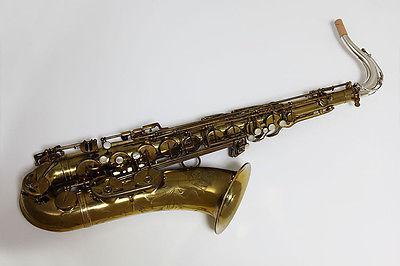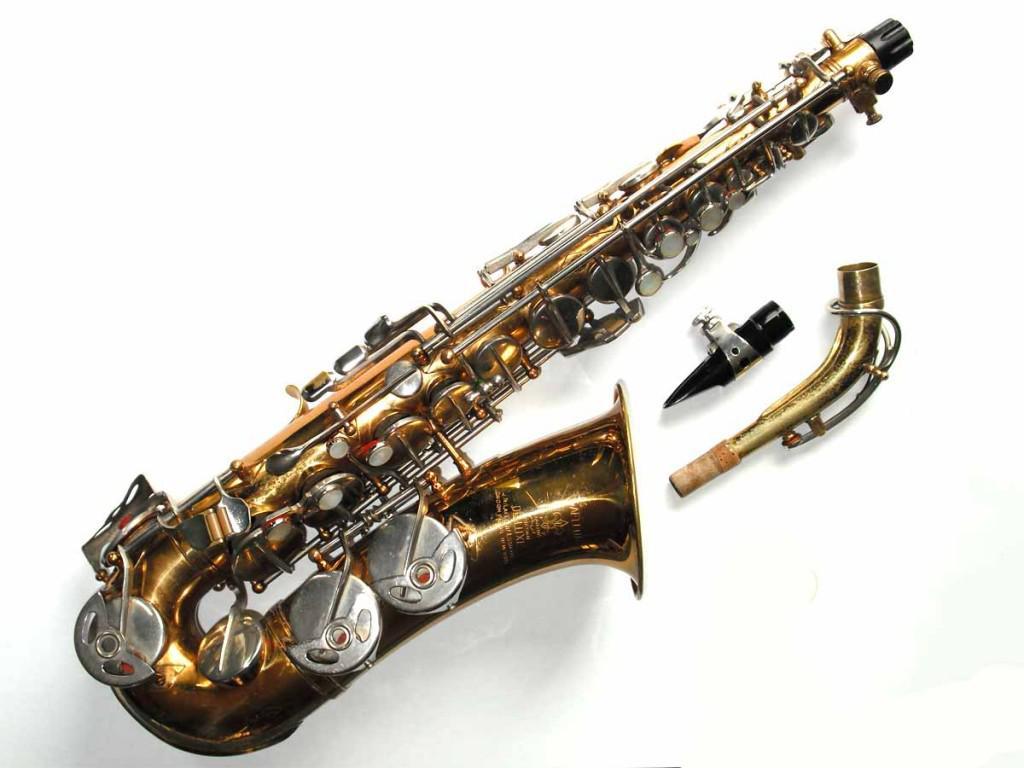The first image is the image on the left, the second image is the image on the right. Evaluate the accuracy of this statement regarding the images: "The saxophones are all sitting upright and facing to the right.". Is it true? Answer yes or no. No. 